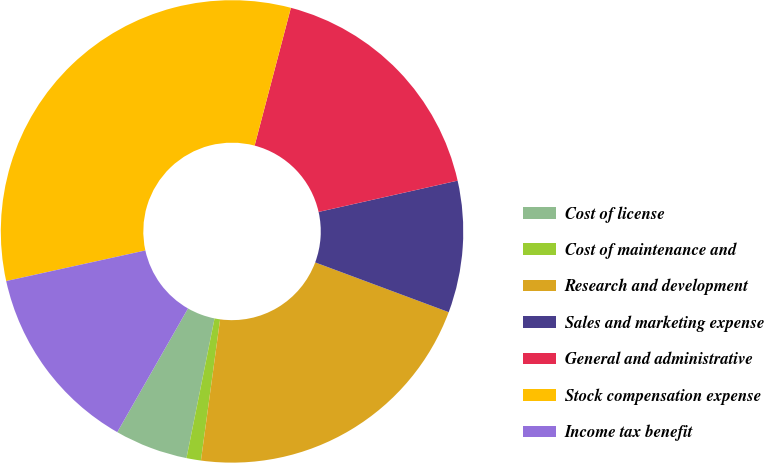Convert chart to OTSL. <chart><loc_0><loc_0><loc_500><loc_500><pie_chart><fcel>Cost of license<fcel>Cost of maintenance and<fcel>Research and development<fcel>Sales and marketing expense<fcel>General and administrative<fcel>Stock compensation expense<fcel>Income tax benefit<nl><fcel>5.11%<fcel>1.01%<fcel>21.47%<fcel>9.2%<fcel>17.38%<fcel>32.54%<fcel>13.29%<nl></chart> 